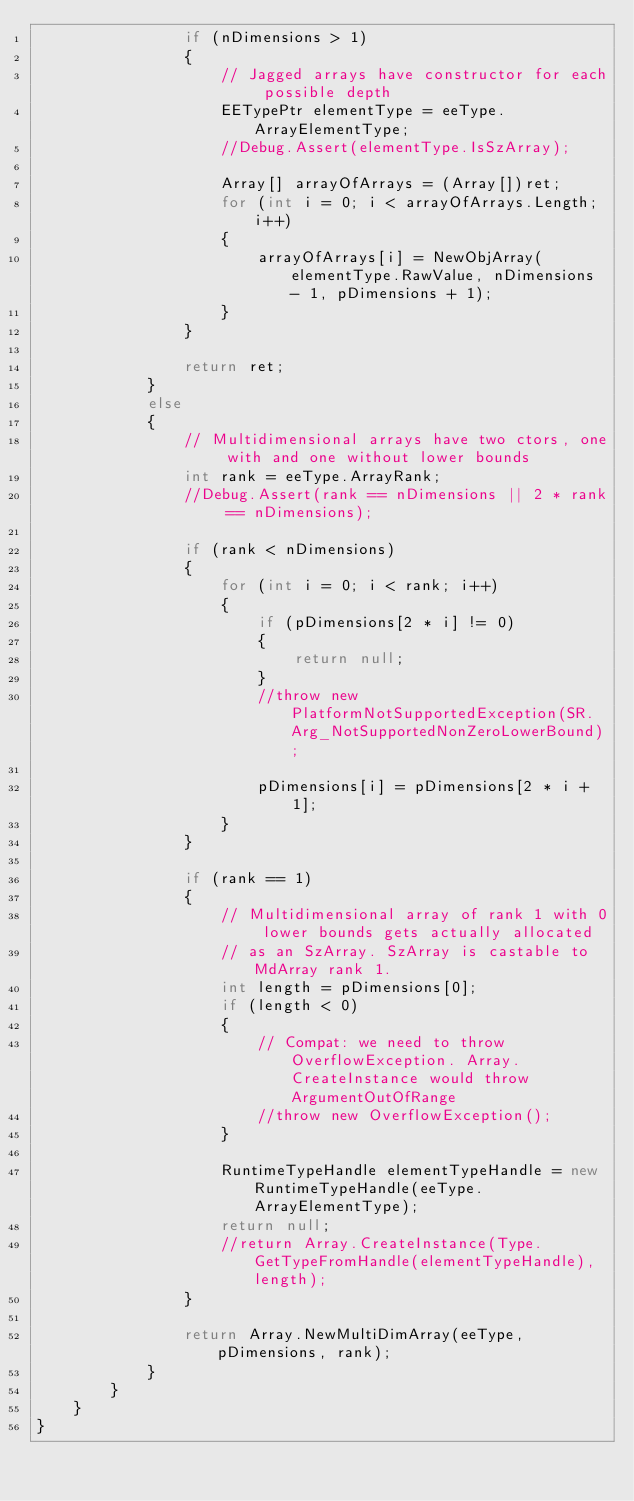<code> <loc_0><loc_0><loc_500><loc_500><_C#_>                if (nDimensions > 1)
                {
                    // Jagged arrays have constructor for each possible depth
                    EETypePtr elementType = eeType.ArrayElementType;
                    //Debug.Assert(elementType.IsSzArray);

                    Array[] arrayOfArrays = (Array[])ret;
                    for (int i = 0; i < arrayOfArrays.Length; i++)
                    {
                        arrayOfArrays[i] = NewObjArray(elementType.RawValue, nDimensions - 1, pDimensions + 1);
                    }
                }

                return ret;
            }
            else
            {
                // Multidimensional arrays have two ctors, one with and one without lower bounds
                int rank = eeType.ArrayRank;
                //Debug.Assert(rank == nDimensions || 2 * rank == nDimensions);

                if (rank < nDimensions)
                {
                    for (int i = 0; i < rank; i++)
                    {
                        if (pDimensions[2 * i] != 0)
                        {
                            return null;
                        }
                        //throw new PlatformNotSupportedException(SR.Arg_NotSupportedNonZeroLowerBound);

                        pDimensions[i] = pDimensions[2 * i + 1];
                    }
                }

                if (rank == 1)
                {
                    // Multidimensional array of rank 1 with 0 lower bounds gets actually allocated
                    // as an SzArray. SzArray is castable to MdArray rank 1.
                    int length = pDimensions[0];
                    if (length < 0)
                    {
                        // Compat: we need to throw OverflowException. Array.CreateInstance would throw ArgumentOutOfRange
                        //throw new OverflowException();
                    }

                    RuntimeTypeHandle elementTypeHandle = new RuntimeTypeHandle(eeType.ArrayElementType);
                    return null;
                    //return Array.CreateInstance(Type.GetTypeFromHandle(elementTypeHandle), length);
                }

                return Array.NewMultiDimArray(eeType, pDimensions, rank);
            }
        }
    }
}</code> 